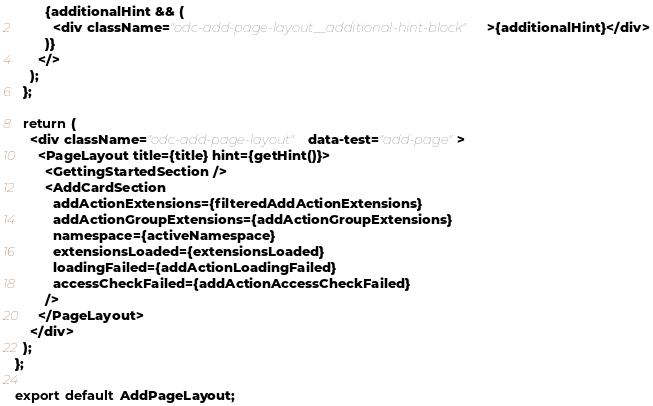<code> <loc_0><loc_0><loc_500><loc_500><_TypeScript_>        {additionalHint && (
          <div className="odc-add-page-layout__additional-hint-block">{additionalHint}</div>
        )}
      </>
    );
  };

  return (
    <div className="odc-add-page-layout" data-test="add-page">
      <PageLayout title={title} hint={getHint()}>
        <GettingStartedSection />
        <AddCardSection
          addActionExtensions={filteredAddActionExtensions}
          addActionGroupExtensions={addActionGroupExtensions}
          namespace={activeNamespace}
          extensionsLoaded={extensionsLoaded}
          loadingFailed={addActionLoadingFailed}
          accessCheckFailed={addActionAccessCheckFailed}
        />
      </PageLayout>
    </div>
  );
};

export default AddPageLayout;
</code> 